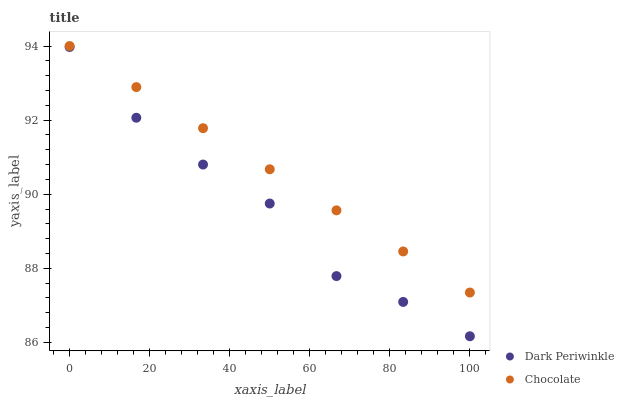Does Dark Periwinkle have the minimum area under the curve?
Answer yes or no. Yes. Does Chocolate have the maximum area under the curve?
Answer yes or no. Yes. Does Chocolate have the minimum area under the curve?
Answer yes or no. No. Is Chocolate the smoothest?
Answer yes or no. Yes. Is Dark Periwinkle the roughest?
Answer yes or no. Yes. Is Chocolate the roughest?
Answer yes or no. No. Does Dark Periwinkle have the lowest value?
Answer yes or no. Yes. Does Chocolate have the lowest value?
Answer yes or no. No. Does Chocolate have the highest value?
Answer yes or no. Yes. Is Dark Periwinkle less than Chocolate?
Answer yes or no. Yes. Is Chocolate greater than Dark Periwinkle?
Answer yes or no. Yes. Does Dark Periwinkle intersect Chocolate?
Answer yes or no. No. 